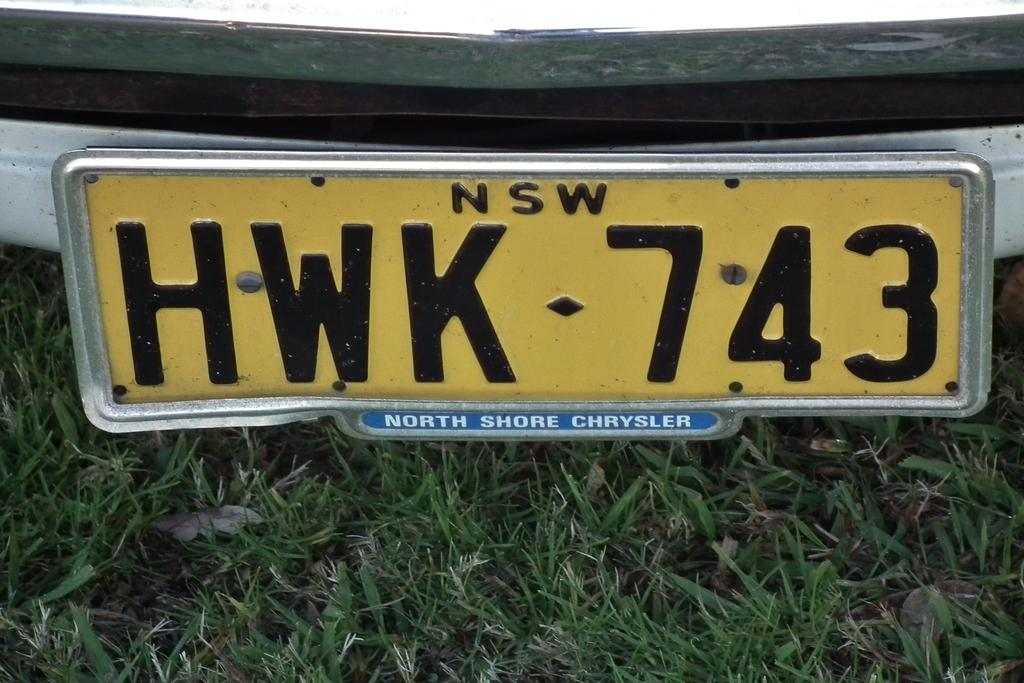<image>
Describe the image concisely. A close up on a yellow license plate shows the characters HWK 743. 